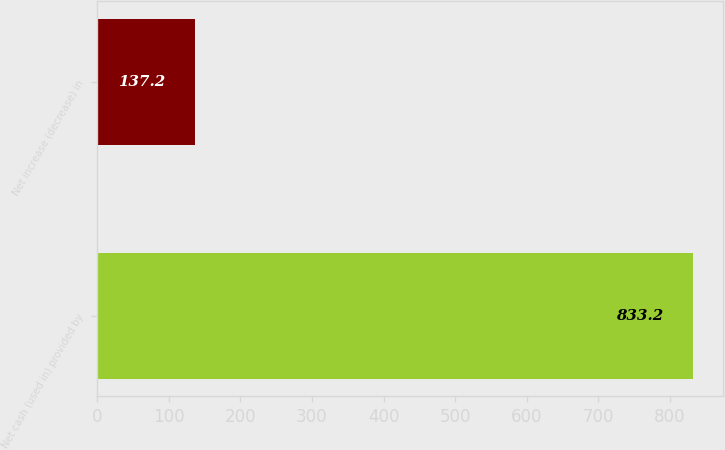Convert chart. <chart><loc_0><loc_0><loc_500><loc_500><bar_chart><fcel>Net cash (used in) provided by<fcel>Net increase (decrease) in<nl><fcel>833.2<fcel>137.2<nl></chart> 